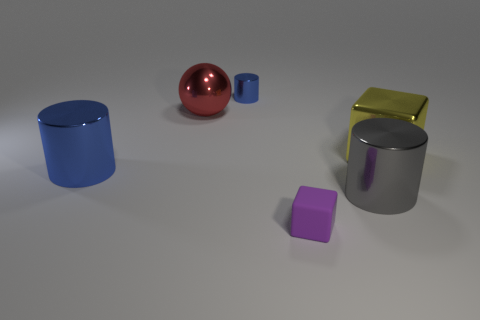Subtract all big metallic cylinders. How many cylinders are left? 1 Subtract all gray cylinders. How many cylinders are left? 2 Subtract 1 balls. How many balls are left? 0 Add 5 big cyan balls. How many big cyan balls exist? 5 Add 2 tiny purple matte cubes. How many objects exist? 8 Subtract 1 yellow cubes. How many objects are left? 5 Subtract all balls. How many objects are left? 5 Subtract all blue cubes. Subtract all brown spheres. How many cubes are left? 2 Subtract all purple balls. How many blue blocks are left? 0 Subtract all small red blocks. Subtract all yellow metallic objects. How many objects are left? 5 